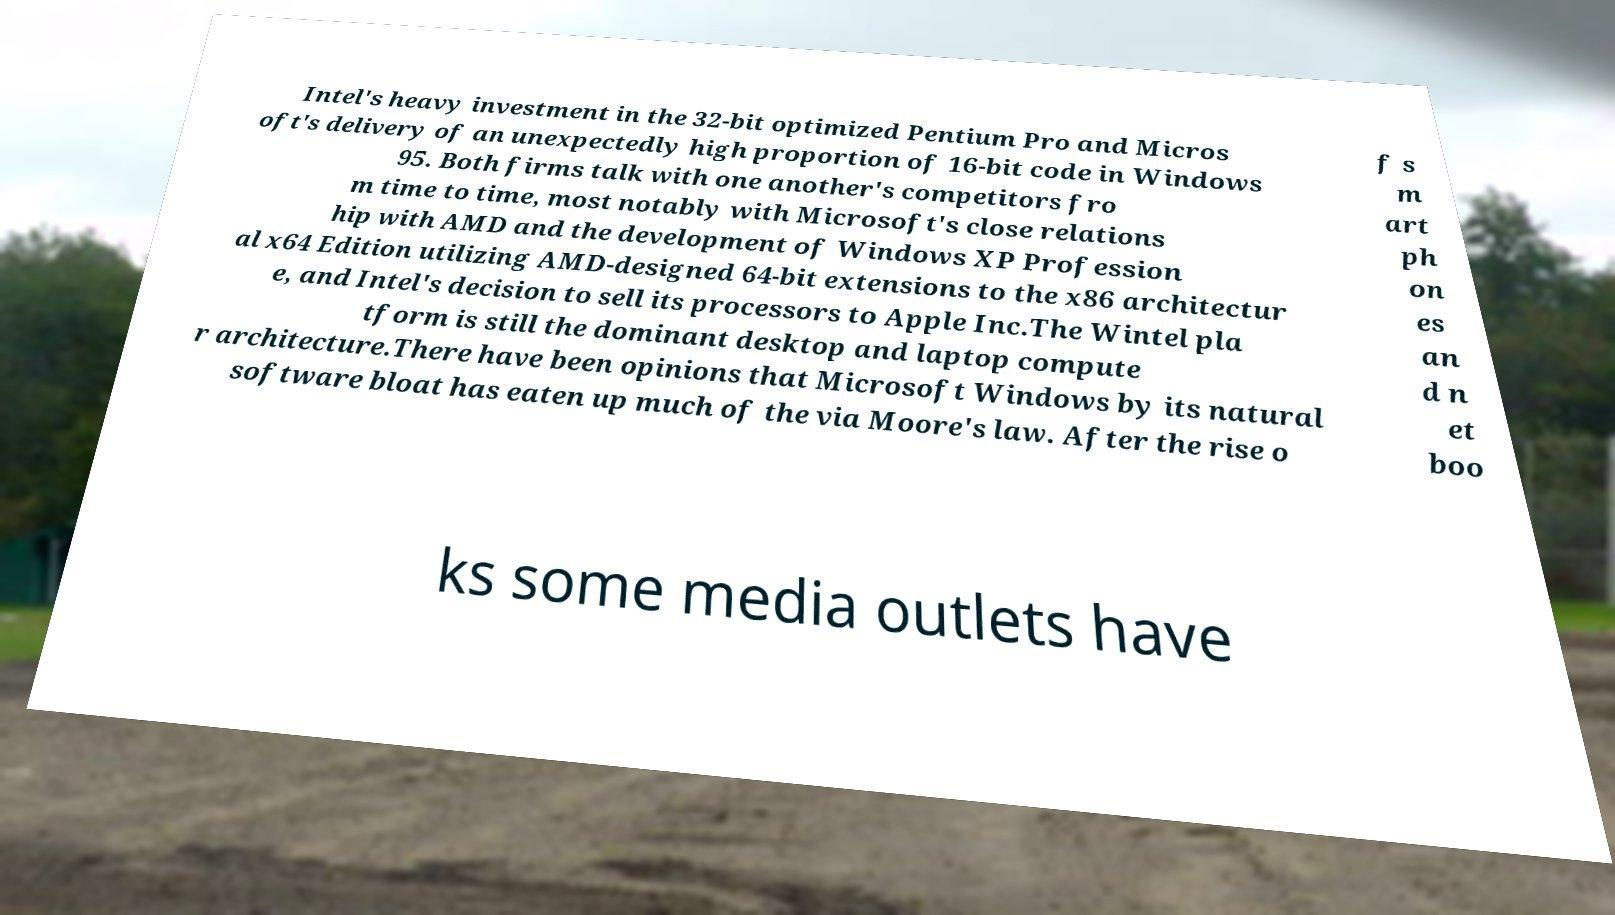Please read and relay the text visible in this image. What does it say? Intel's heavy investment in the 32-bit optimized Pentium Pro and Micros oft's delivery of an unexpectedly high proportion of 16-bit code in Windows 95. Both firms talk with one another's competitors fro m time to time, most notably with Microsoft's close relations hip with AMD and the development of Windows XP Profession al x64 Edition utilizing AMD-designed 64-bit extensions to the x86 architectur e, and Intel's decision to sell its processors to Apple Inc.The Wintel pla tform is still the dominant desktop and laptop compute r architecture.There have been opinions that Microsoft Windows by its natural software bloat has eaten up much of the via Moore's law. After the rise o f s m art ph on es an d n et boo ks some media outlets have 